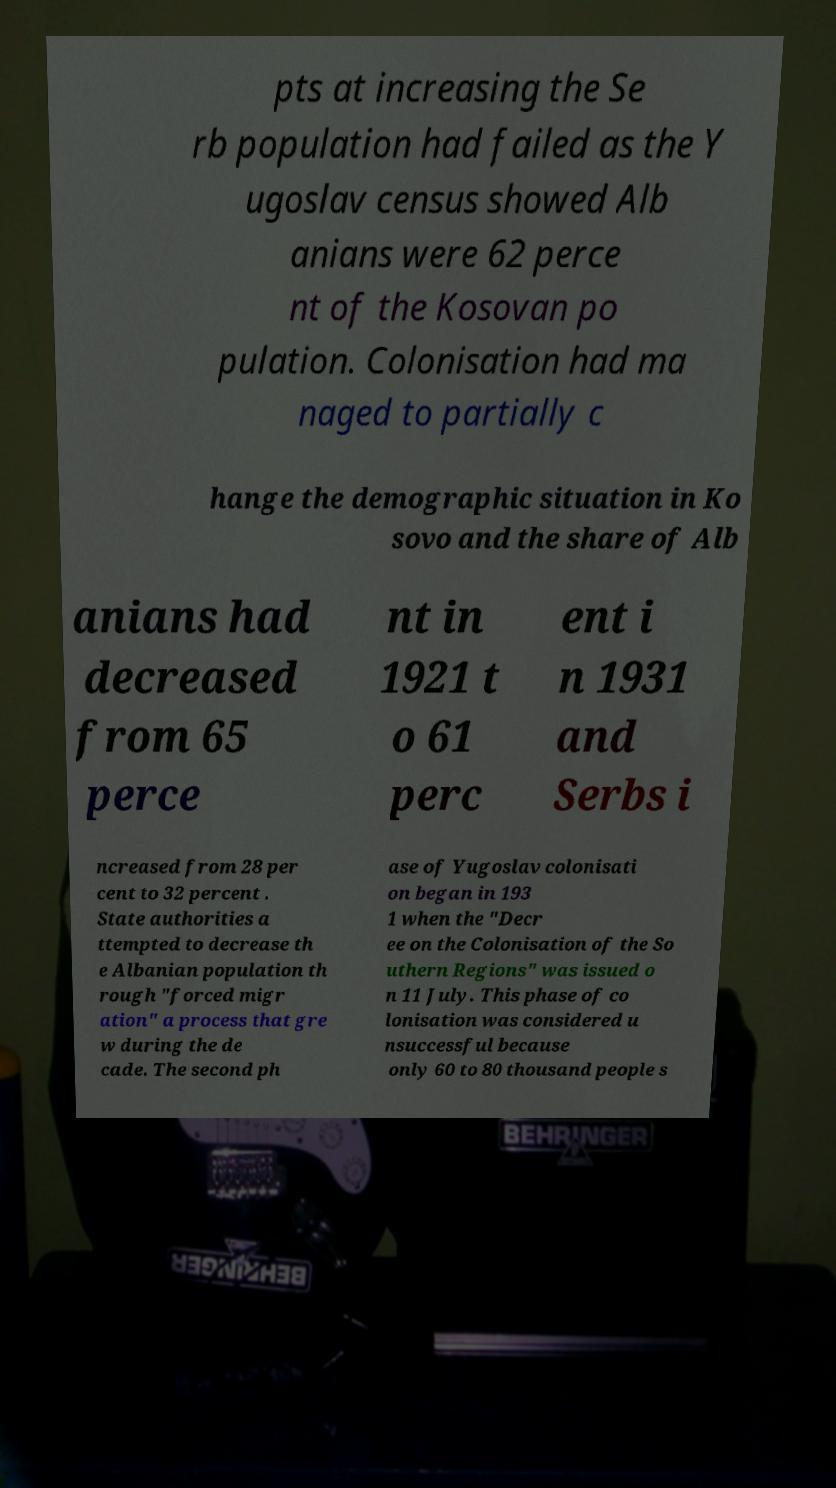What messages or text are displayed in this image? I need them in a readable, typed format. pts at increasing the Se rb population had failed as the Y ugoslav census showed Alb anians were 62 perce nt of the Kosovan po pulation. Colonisation had ma naged to partially c hange the demographic situation in Ko sovo and the share of Alb anians had decreased from 65 perce nt in 1921 t o 61 perc ent i n 1931 and Serbs i ncreased from 28 per cent to 32 percent . State authorities a ttempted to decrease th e Albanian population th rough "forced migr ation" a process that gre w during the de cade. The second ph ase of Yugoslav colonisati on began in 193 1 when the "Decr ee on the Colonisation of the So uthern Regions" was issued o n 11 July. This phase of co lonisation was considered u nsuccessful because only 60 to 80 thousand people s 